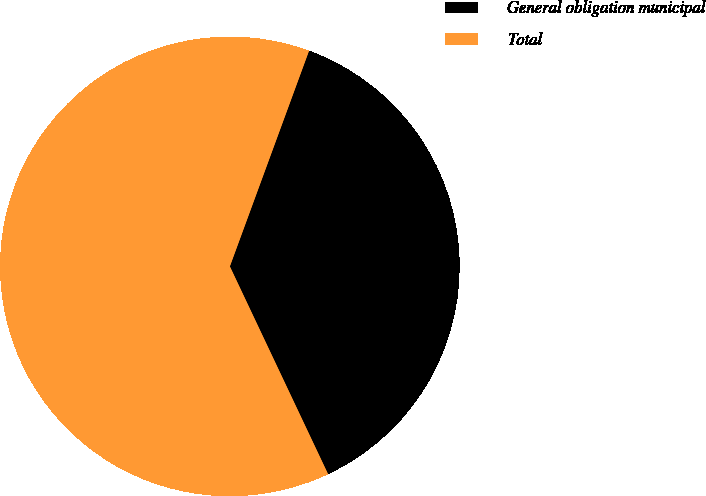<chart> <loc_0><loc_0><loc_500><loc_500><pie_chart><fcel>General obligation municipal<fcel>Total<nl><fcel>37.37%<fcel>62.63%<nl></chart> 